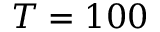Convert formula to latex. <formula><loc_0><loc_0><loc_500><loc_500>T = 1 0 0</formula> 